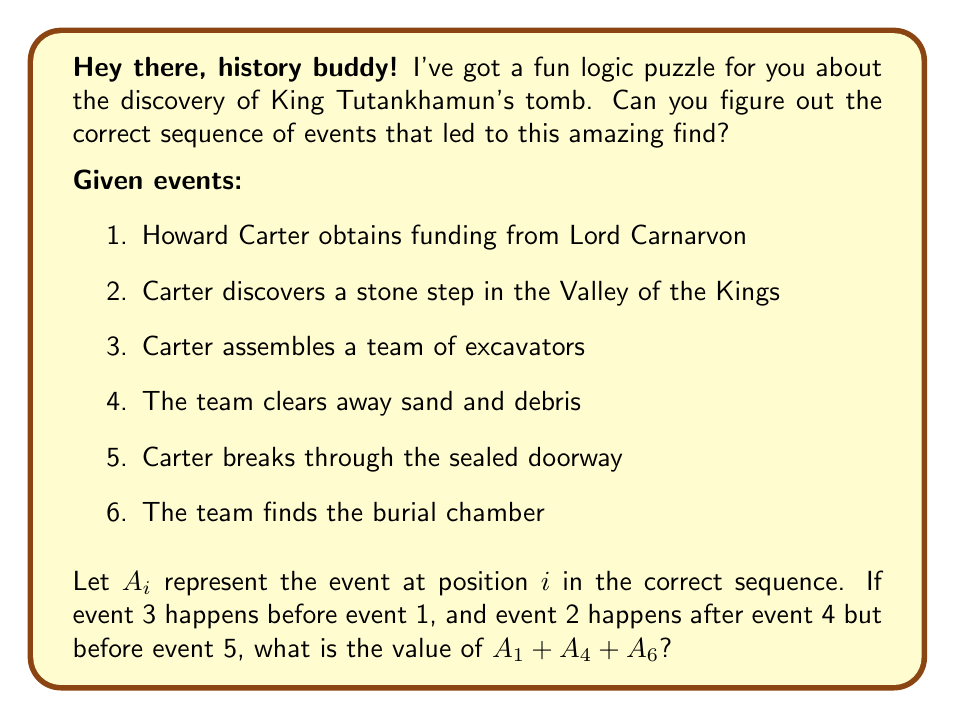Can you answer this question? Let's approach this step-by-step:

1) We know that event 3 happens before event 1. So, A₃ < A₁

2) We also know that event 2 happens after event 4 but before event 5. So, A₄ < A₂ < A₅

3) Combining these facts, we can deduce a partial order:
   A₃ < A₁, A₄ < A₂ < A₅

4) The only event we haven't placed yet is event 6, which logically must come last.

5) So, the full sequence must be:
   A₁ = 3 (Carter assembles a team of excavators)
   A₂ = 1 (Howard Carter obtains funding from Lord Carnarvon)
   A₃ = 4 (The team clears away sand and debris)
   A₄ = 2 (Carter discovers a stone step in the Valley of the Kings)
   A₅ = 5 (Carter breaks through the sealed doorway)
   A₆ = 6 (The team finds the burial chamber)

6) The question asks for A₁ + A₄ + A₆
   = 3 + 2 + 6
   = 11

Therefore, the sum A₁ + A₄ + A₆ = 11.
Answer: 11 